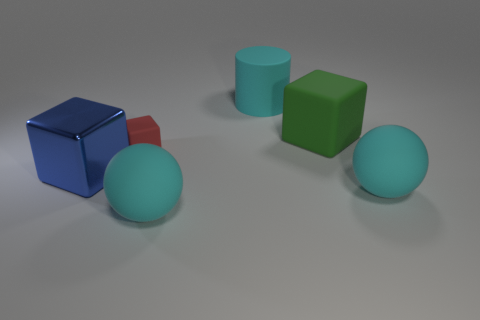Add 4 cyan balls. How many objects exist? 10 Subtract all cylinders. How many objects are left? 5 Add 4 blue cubes. How many blue cubes exist? 5 Subtract 0 purple cubes. How many objects are left? 6 Subtract all large cyan things. Subtract all large blue blocks. How many objects are left? 2 Add 5 large cyan things. How many large cyan things are left? 8 